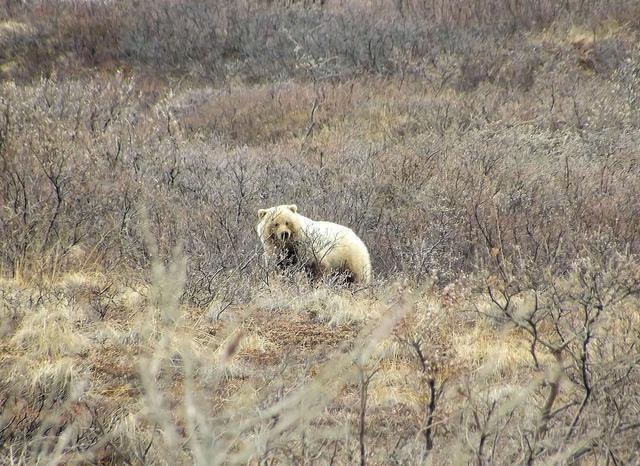How many people are wearing white shirts?
Give a very brief answer. 0. 